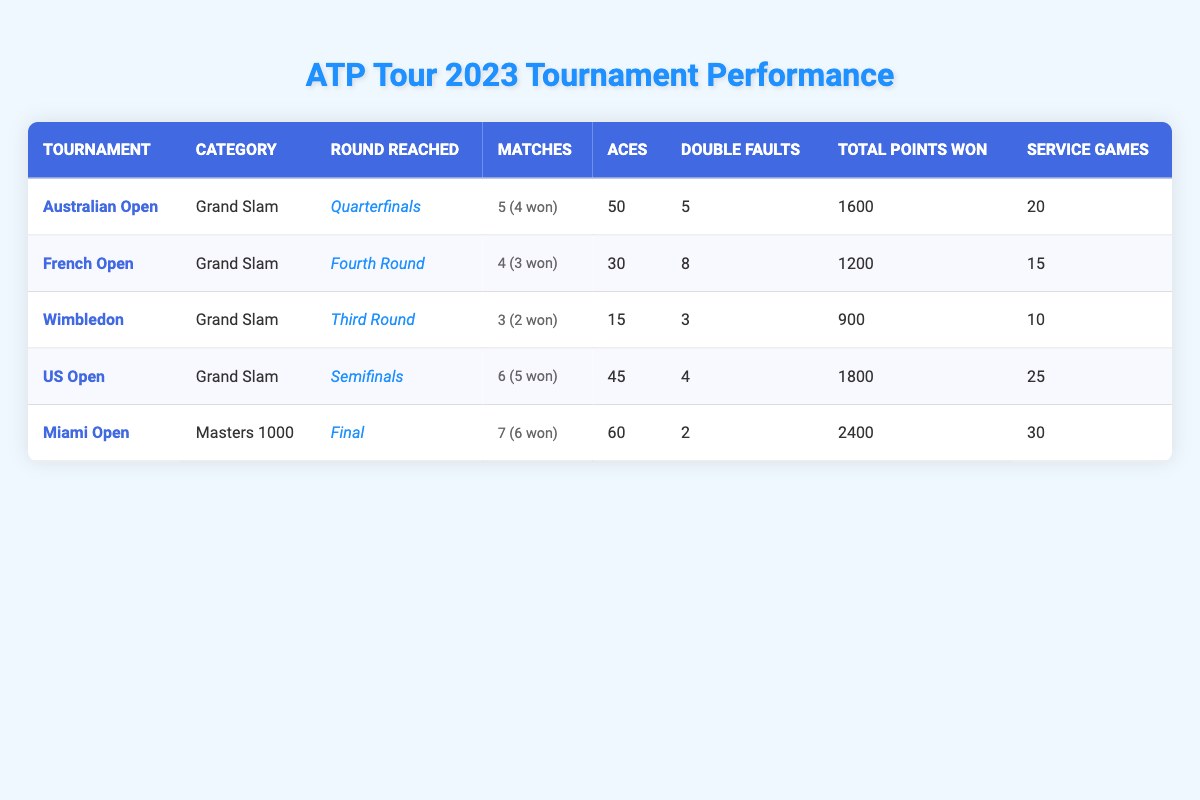What is the total number of matches played in the Grand Slam tournaments? Looking at the Grand Slam tournaments (Australian Open, French Open, Wimbledon, US Open), the number of matches played are: 5, 4, 3, and 6. Summing these gives 5 + 4 + 3 + 6 = 18.
Answer: 18 Which tournament had the highest number of aces? Checking the aces in each tournament: Australian Open has 50, French Open has 30, Wimbledon has 15, US Open has 45, and Miami Open has 60. The highest number is 60 in the Miami Open.
Answer: 60 How many matches were won in total across all tournaments? The total matches won are: Australian Open 4, French Open 3, Wimbledon 2, US Open 5, and Miami Open 6. Summing these gives 4 + 3 + 2 + 5 + 6 = 20 matches won in total.
Answer: 20 Did the player achieve more than 2000 total points won in any tournament? The total points won are: Australian Open 1600, French Open 1200, Wimbledon 900, US Open 1800, and Miami Open 2400. Since 2400 is greater than 2000, the answer is yes.
Answer: Yes What is the average number of double faults across all tournaments? The double faults are: Australian Open 5, French Open 8, Wimbledon 3, US Open 4, and Miami Open 2. The total is 5 + 8 + 3 + 4 + 2 = 22. With 5 tournaments, the average is 22 / 5 = 4.4.
Answer: 4.4 In which tournament did the player reach the least advanced round? The rounds reached are: Australian Open (Quarterfinals), French Open (Fourth Round), Wimbledon (Third Round), US Open (Semifinals), and Miami Open (Final). The least advanced round is Third Round at Wimbledon.
Answer: Wimbledon What is the difference in matches played between the tournament with the most matches and the tournament with the least matches? The matches played are: Australian Open 5, French Open 4, Wimbledon 3, US Open 6, Miami Open 7. The maximum is 7 (Miami Open) and the minimum is 3 (Wimbledon). The difference is 7 - 3 = 4 matches.
Answer: 4 How many service games were played in total across all tournaments? The total service games are: Australian Open 20, French Open 15, Wimbledon 10, US Open 25, and Miami Open 30. Summing these gives 20 + 15 + 10 + 25 + 30 = 100 service games in total.
Answer: 100 